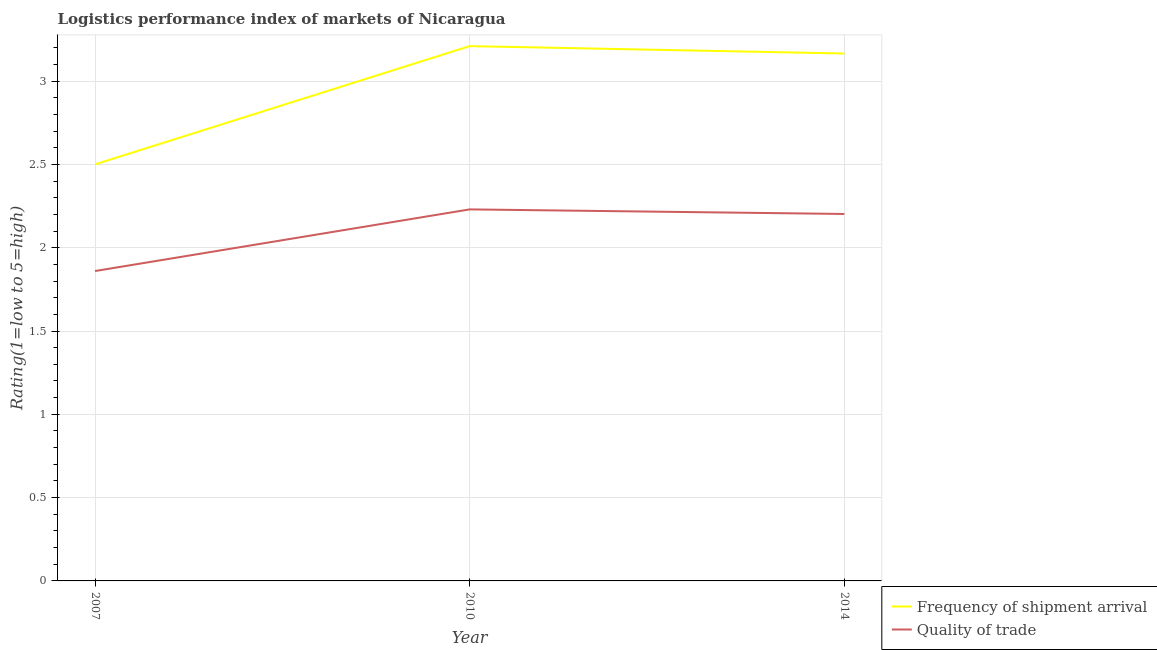Does the line corresponding to lpi quality of trade intersect with the line corresponding to lpi of frequency of shipment arrival?
Offer a very short reply. No. What is the lpi quality of trade in 2007?
Keep it short and to the point. 1.86. Across all years, what is the maximum lpi quality of trade?
Offer a very short reply. 2.23. Across all years, what is the minimum lpi quality of trade?
Your answer should be compact. 1.86. In which year was the lpi of frequency of shipment arrival maximum?
Provide a short and direct response. 2010. What is the total lpi quality of trade in the graph?
Your response must be concise. 6.29. What is the difference between the lpi quality of trade in 2010 and that in 2014?
Your response must be concise. 0.03. What is the difference between the lpi of frequency of shipment arrival in 2007 and the lpi quality of trade in 2010?
Your answer should be very brief. 0.27. What is the average lpi quality of trade per year?
Provide a short and direct response. 2.1. In the year 2010, what is the difference between the lpi of frequency of shipment arrival and lpi quality of trade?
Your response must be concise. 0.98. What is the ratio of the lpi quality of trade in 2010 to that in 2014?
Offer a very short reply. 1.01. Is the difference between the lpi of frequency of shipment arrival in 2007 and 2014 greater than the difference between the lpi quality of trade in 2007 and 2014?
Offer a very short reply. No. What is the difference between the highest and the second highest lpi of frequency of shipment arrival?
Your answer should be very brief. 0.04. What is the difference between the highest and the lowest lpi quality of trade?
Give a very brief answer. 0.37. In how many years, is the lpi quality of trade greater than the average lpi quality of trade taken over all years?
Offer a very short reply. 2. Is the sum of the lpi of frequency of shipment arrival in 2010 and 2014 greater than the maximum lpi quality of trade across all years?
Ensure brevity in your answer.  Yes. How many years are there in the graph?
Your response must be concise. 3. Are the values on the major ticks of Y-axis written in scientific E-notation?
Keep it short and to the point. No. Does the graph contain any zero values?
Offer a terse response. No. How many legend labels are there?
Make the answer very short. 2. How are the legend labels stacked?
Keep it short and to the point. Vertical. What is the title of the graph?
Your response must be concise. Logistics performance index of markets of Nicaragua. What is the label or title of the Y-axis?
Your answer should be very brief. Rating(1=low to 5=high). What is the Rating(1=low to 5=high) in Frequency of shipment arrival in 2007?
Offer a very short reply. 2.5. What is the Rating(1=low to 5=high) in Quality of trade in 2007?
Your answer should be compact. 1.86. What is the Rating(1=low to 5=high) in Frequency of shipment arrival in 2010?
Give a very brief answer. 3.21. What is the Rating(1=low to 5=high) of Quality of trade in 2010?
Offer a very short reply. 2.23. What is the Rating(1=low to 5=high) of Frequency of shipment arrival in 2014?
Ensure brevity in your answer.  3.17. What is the Rating(1=low to 5=high) in Quality of trade in 2014?
Provide a short and direct response. 2.2. Across all years, what is the maximum Rating(1=low to 5=high) in Frequency of shipment arrival?
Offer a very short reply. 3.21. Across all years, what is the maximum Rating(1=low to 5=high) in Quality of trade?
Your response must be concise. 2.23. Across all years, what is the minimum Rating(1=low to 5=high) of Quality of trade?
Keep it short and to the point. 1.86. What is the total Rating(1=low to 5=high) of Frequency of shipment arrival in the graph?
Your answer should be compact. 8.88. What is the total Rating(1=low to 5=high) of Quality of trade in the graph?
Keep it short and to the point. 6.29. What is the difference between the Rating(1=low to 5=high) in Frequency of shipment arrival in 2007 and that in 2010?
Your answer should be compact. -0.71. What is the difference between the Rating(1=low to 5=high) of Quality of trade in 2007 and that in 2010?
Your answer should be compact. -0.37. What is the difference between the Rating(1=low to 5=high) of Frequency of shipment arrival in 2007 and that in 2014?
Make the answer very short. -0.67. What is the difference between the Rating(1=low to 5=high) of Quality of trade in 2007 and that in 2014?
Provide a succinct answer. -0.34. What is the difference between the Rating(1=low to 5=high) of Frequency of shipment arrival in 2010 and that in 2014?
Keep it short and to the point. 0.04. What is the difference between the Rating(1=low to 5=high) of Quality of trade in 2010 and that in 2014?
Your response must be concise. 0.03. What is the difference between the Rating(1=low to 5=high) of Frequency of shipment arrival in 2007 and the Rating(1=low to 5=high) of Quality of trade in 2010?
Your answer should be very brief. 0.27. What is the difference between the Rating(1=low to 5=high) of Frequency of shipment arrival in 2007 and the Rating(1=low to 5=high) of Quality of trade in 2014?
Offer a very short reply. 0.3. What is the difference between the Rating(1=low to 5=high) of Frequency of shipment arrival in 2010 and the Rating(1=low to 5=high) of Quality of trade in 2014?
Your answer should be very brief. 1.01. What is the average Rating(1=low to 5=high) of Frequency of shipment arrival per year?
Provide a short and direct response. 2.96. What is the average Rating(1=low to 5=high) in Quality of trade per year?
Your answer should be compact. 2.1. In the year 2007, what is the difference between the Rating(1=low to 5=high) in Frequency of shipment arrival and Rating(1=low to 5=high) in Quality of trade?
Offer a very short reply. 0.64. In the year 2010, what is the difference between the Rating(1=low to 5=high) of Frequency of shipment arrival and Rating(1=low to 5=high) of Quality of trade?
Keep it short and to the point. 0.98. In the year 2014, what is the difference between the Rating(1=low to 5=high) of Frequency of shipment arrival and Rating(1=low to 5=high) of Quality of trade?
Give a very brief answer. 0.96. What is the ratio of the Rating(1=low to 5=high) in Frequency of shipment arrival in 2007 to that in 2010?
Your answer should be compact. 0.78. What is the ratio of the Rating(1=low to 5=high) of Quality of trade in 2007 to that in 2010?
Keep it short and to the point. 0.83. What is the ratio of the Rating(1=low to 5=high) in Frequency of shipment arrival in 2007 to that in 2014?
Offer a terse response. 0.79. What is the ratio of the Rating(1=low to 5=high) of Quality of trade in 2007 to that in 2014?
Your answer should be compact. 0.84. What is the ratio of the Rating(1=low to 5=high) of Frequency of shipment arrival in 2010 to that in 2014?
Offer a very short reply. 1.01. What is the ratio of the Rating(1=low to 5=high) of Quality of trade in 2010 to that in 2014?
Provide a succinct answer. 1.01. What is the difference between the highest and the second highest Rating(1=low to 5=high) in Frequency of shipment arrival?
Offer a very short reply. 0.04. What is the difference between the highest and the second highest Rating(1=low to 5=high) in Quality of trade?
Ensure brevity in your answer.  0.03. What is the difference between the highest and the lowest Rating(1=low to 5=high) of Frequency of shipment arrival?
Make the answer very short. 0.71. What is the difference between the highest and the lowest Rating(1=low to 5=high) in Quality of trade?
Your response must be concise. 0.37. 